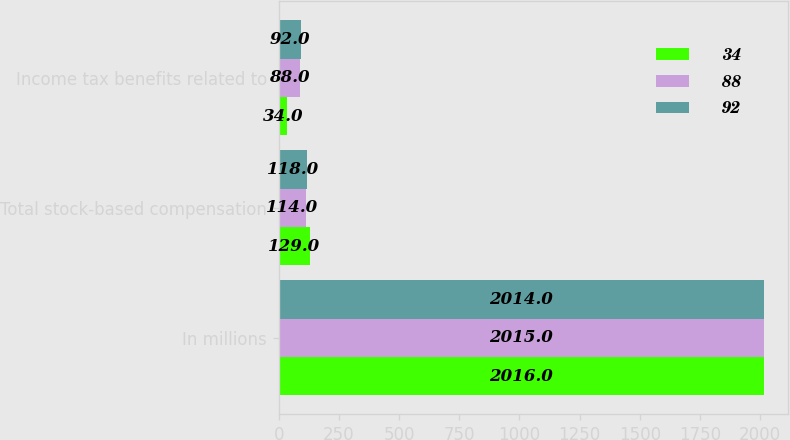<chart> <loc_0><loc_0><loc_500><loc_500><stacked_bar_chart><ecel><fcel>In millions<fcel>Total stock-based compensation<fcel>Income tax benefits related to<nl><fcel>34<fcel>2016<fcel>129<fcel>34<nl><fcel>88<fcel>2015<fcel>114<fcel>88<nl><fcel>92<fcel>2014<fcel>118<fcel>92<nl></chart> 